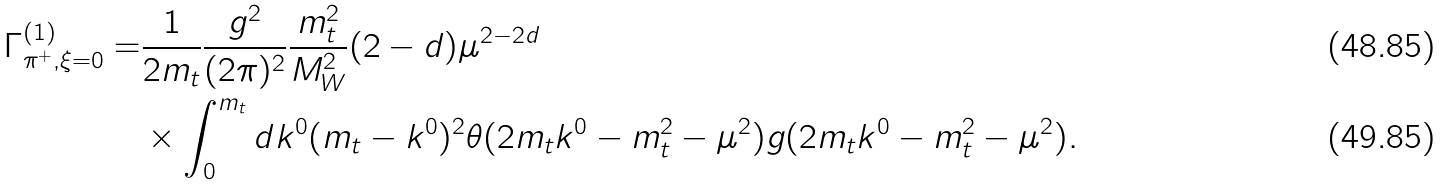<formula> <loc_0><loc_0><loc_500><loc_500>\Gamma _ { \pi ^ { + } , \xi = 0 } ^ { ( 1 ) } = & \frac { 1 } { 2 m _ { t } } \frac { g ^ { 2 } } { ( 2 \pi ) ^ { 2 } } \frac { m _ { t } ^ { 2 } } { M _ { W } ^ { 2 } } ( 2 - d ) \mu ^ { 2 - 2 d } \\ & \times \int _ { 0 } ^ { m _ { t } } d k ^ { 0 } ( m _ { t } - k ^ { 0 } ) ^ { 2 } \theta ( 2 m _ { t } k ^ { 0 } - m _ { t } ^ { 2 } - \mu ^ { 2 } ) g ( 2 m _ { t } k ^ { 0 } - m _ { t } ^ { 2 } - \mu ^ { 2 } ) .</formula> 